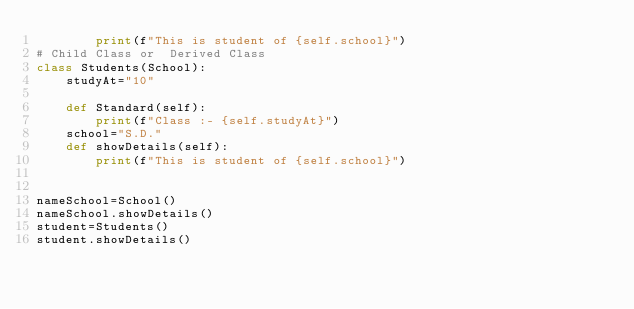<code> <loc_0><loc_0><loc_500><loc_500><_Python_>        print(f"This is student of {self.school}")
# Child Class or  Derived Class
class Students(School):
    studyAt="10"
    
    def Standard(self):
        print(f"Class :- {self.studyAt}")
    school="S.D."
    def showDetails(self):
        print(f"This is student of {self.school}")


nameSchool=School()
nameSchool.showDetails()
student=Students()
student.showDetails()</code> 